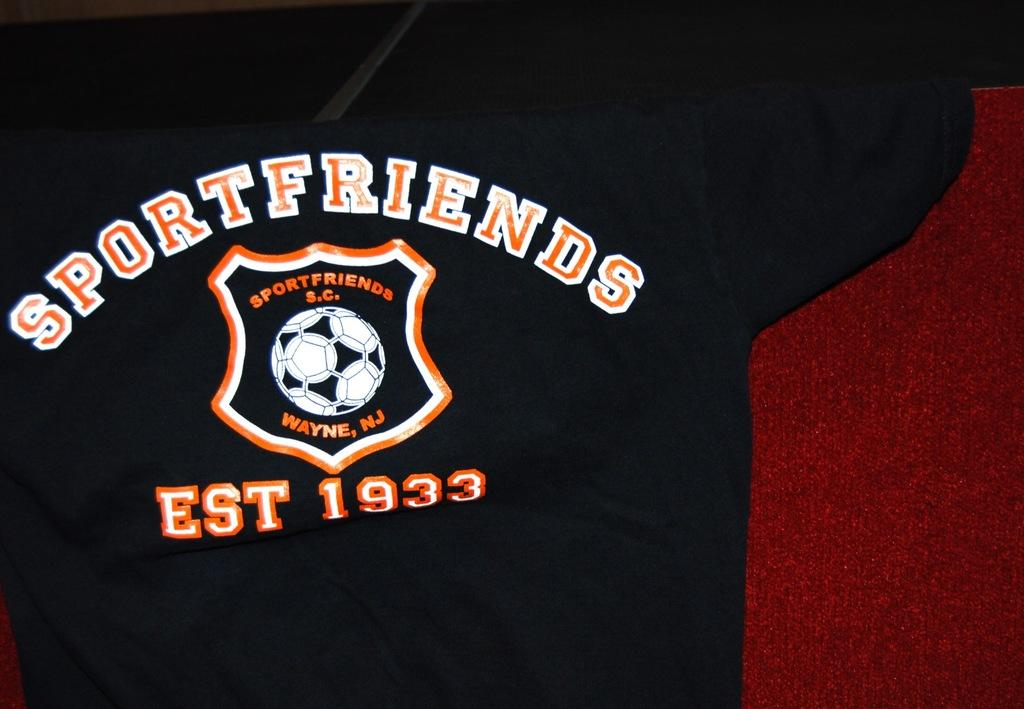<image>
Write a terse but informative summary of the picture. A black Sportfriends shirt has a white and orange soccer ball logo with text indicating an establishment date of 1933. 